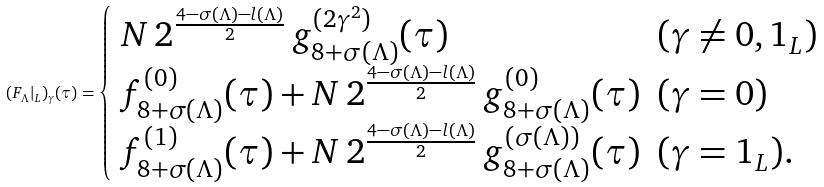<formula> <loc_0><loc_0><loc_500><loc_500>( F _ { \Lambda } | _ { L } ) _ { \gamma } ( \tau ) = \begin{cases} \begin{array} { l l } N \, 2 ^ { \frac { 4 - \sigma ( \Lambda ) - l ( \Lambda ) } { 2 } } \, g ^ { ( 2 \gamma ^ { 2 } ) } _ { 8 + \sigma ( \Lambda ) } ( \tau ) & ( \gamma \not = 0 , { 1 } _ { L } ) \\ f ^ { ( 0 ) } _ { 8 + \sigma ( \Lambda ) } ( \tau ) + N \, 2 ^ { \frac { 4 - \sigma ( \Lambda ) - l ( \Lambda ) } { 2 } } \, g ^ { ( 0 ) } _ { 8 + \sigma ( \Lambda ) } ( \tau ) & ( \gamma = 0 ) \\ f ^ { ( 1 ) } _ { 8 + \sigma ( \Lambda ) } ( \tau ) + N \, 2 ^ { \frac { 4 - \sigma ( \Lambda ) - l ( \Lambda ) } { 2 } } \, g ^ { ( \sigma ( \Lambda ) ) } _ { 8 + \sigma ( \Lambda ) } ( \tau ) & ( \gamma = { 1 } _ { L } ) . \end{array} \end{cases}</formula> 